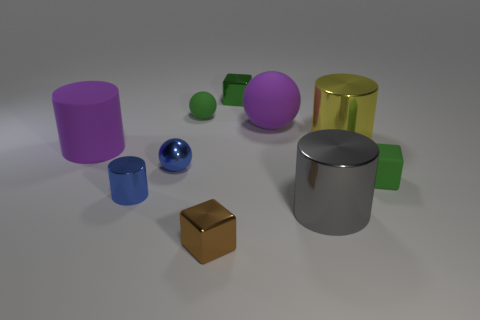Can you tell me what materials the objects in this image might be made from? The objects in the image seem to be made from various materials that include metallic surfaces, as evidenced by the reflective sheen on the silver cylinder and the golden cube, and matte finishes that can be observed on the purple cylinder and the green shapes. 